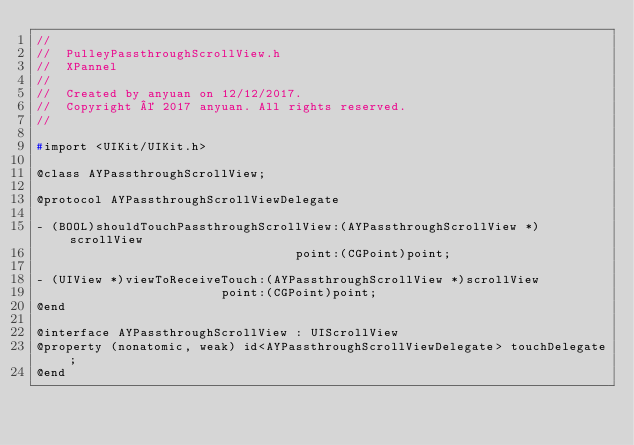<code> <loc_0><loc_0><loc_500><loc_500><_C_>//
//  PulleyPassthroughScrollView.h
//  XPannel
//
//  Created by anyuan on 12/12/2017.
//  Copyright © 2017 anyuan. All rights reserved.
//

#import <UIKit/UIKit.h>

@class AYPassthroughScrollView;

@protocol AYPassthroughScrollViewDelegate

- (BOOL)shouldTouchPassthroughScrollView:(AYPassthroughScrollView *)scrollView
                                   point:(CGPoint)point;

- (UIView *)viewToReceiveTouch:(AYPassthroughScrollView *)scrollView
                         point:(CGPoint)point;
@end

@interface AYPassthroughScrollView : UIScrollView
@property (nonatomic, weak) id<AYPassthroughScrollViewDelegate> touchDelegate;
@end
</code> 